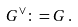<formula> <loc_0><loc_0><loc_500><loc_500>G ^ { \vee } \colon = G \, .</formula> 